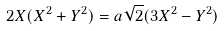<formula> <loc_0><loc_0><loc_500><loc_500>2 X ( X ^ { 2 } + Y ^ { 2 } ) = a { \sqrt { 2 } } ( 3 X ^ { 2 } - Y ^ { 2 } )</formula> 